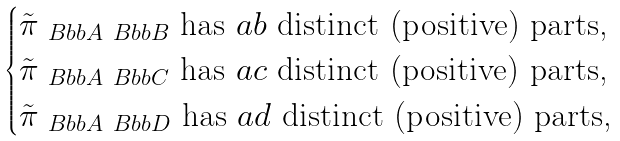<formula> <loc_0><loc_0><loc_500><loc_500>\begin{cases} \tilde { \pi } _ { \ B b b A \ B b b B } \text { has $ab$ distinct (positive) parts,} \\ \tilde { \pi } _ { \ B b b A \ B b b C } \text { has $ac$ distinct (positive) parts,} \\ \tilde { \pi } _ { \ B b b A \ B b b D } \text { has $ad$ distinct (positive) parts,} \end{cases}</formula> 